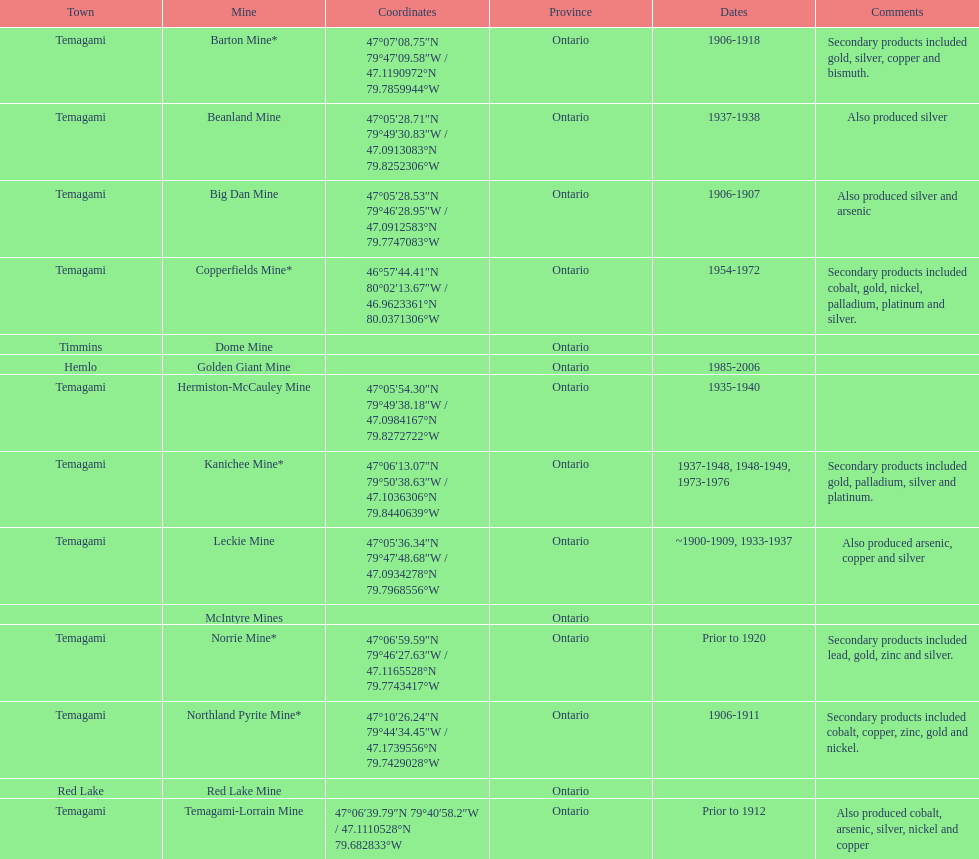Which mine was open longer, golden giant or beanland mine? Golden Giant Mine. 